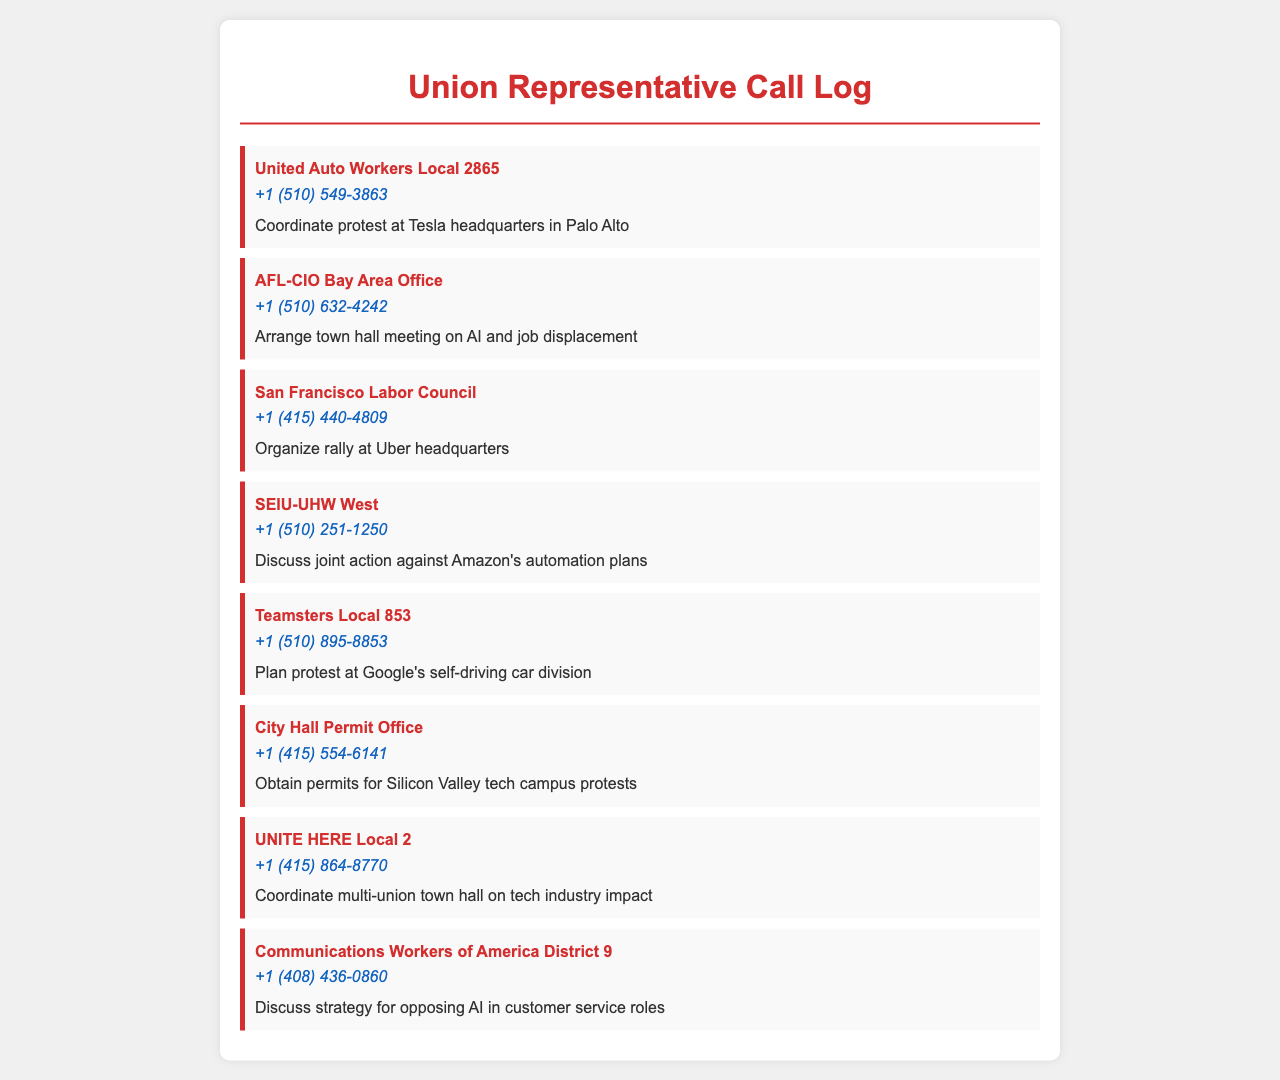what is the first contact in the call log? The first contact listed in the call log is United Auto Workers Local 2865.
Answer: United Auto Workers Local 2865 what is the purpose of the call to AFL-CIO Bay Area Office? The purpose stated for this call is to arrange a town hall meeting on AI and job displacement.
Answer: Arrange town hall meeting on AI and job displacement how many calls are made to labor councils? There are three calls made to labor councils: San Francisco Labor Council, SEIU-UHW West, and UNITE HERE Local 2.
Answer: Three what is the phone number for the City Hall Permit Office? The City Hall Permit Office's phone number is +1 (415) 554-6141.
Answer: +1 (415) 554-6141 which tech company headquarters is mentioned for coordinating a protest? The call log mentions a protest coordinated at Tesla headquarters in Palo Alto.
Answer: Tesla headquarters in Palo Alto what type of meeting is being coordinated by UNITE HERE Local 2? UNITE HERE Local 2 is coordinating a multi-union town hall on tech industry impact.
Answer: Multi-union town hall on tech industry impact which organization is contacted to discuss strategy for opposing AI in customer service roles? The organization contacted is Communications Workers of America District 9.
Answer: Communications Workers of America District 9 how many different purposes are mentioned for the calls? There are seven different purposes mentioned for the calls in the log.
Answer: Seven 